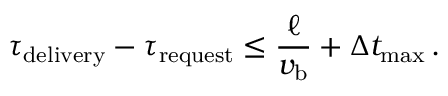Convert formula to latex. <formula><loc_0><loc_0><loc_500><loc_500>\tau _ { d e l i v e r y } - \tau _ { r e q u e s t } \leq \frac { \ell } { v _ { b } } + \Delta t _ { \max } \, .</formula> 